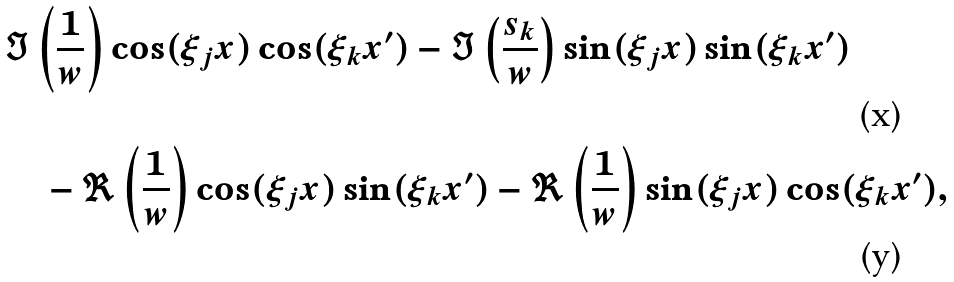Convert formula to latex. <formula><loc_0><loc_0><loc_500><loc_500>& \Im \left ( \frac { 1 } { w } \right ) \cos ( \xi _ { j } x ) \cos ( \xi _ { k } x ^ { \prime } ) - \Im \left ( \frac { s _ { k } } { w } \right ) \sin ( \xi _ { j } x ) \sin ( \xi _ { k } x ^ { \prime } ) \\ & \quad \strut - \Re \left ( \frac { 1 } { w } \right ) \cos ( \xi _ { j } x ) \sin ( \xi _ { k } x ^ { \prime } ) - \Re \left ( \frac { 1 } { w } \right ) \sin ( \xi _ { j } x ) \cos ( \xi _ { k } x ^ { \prime } ) ,</formula> 